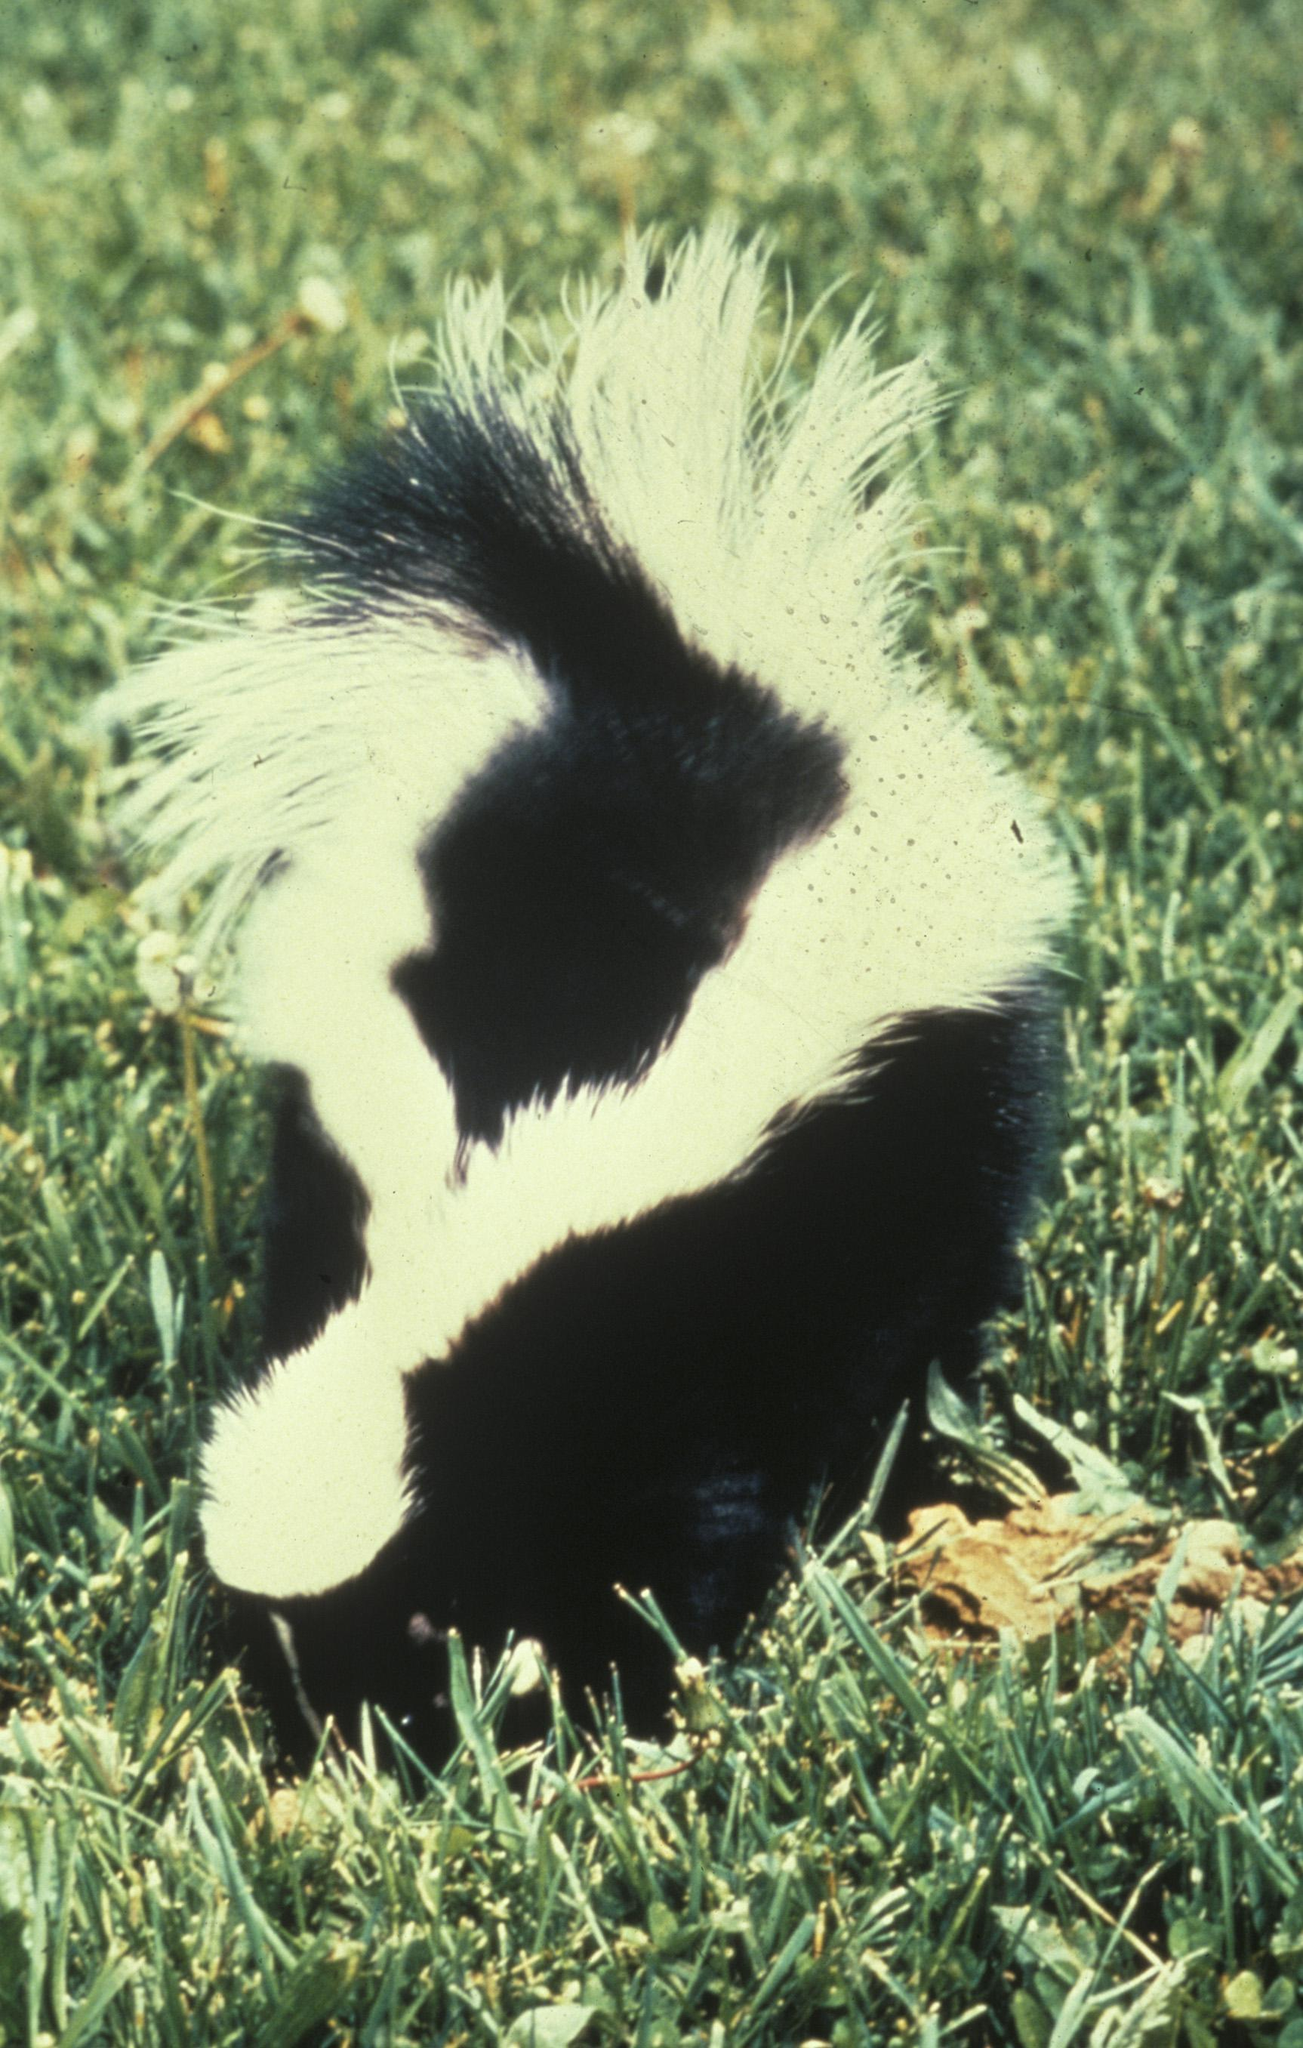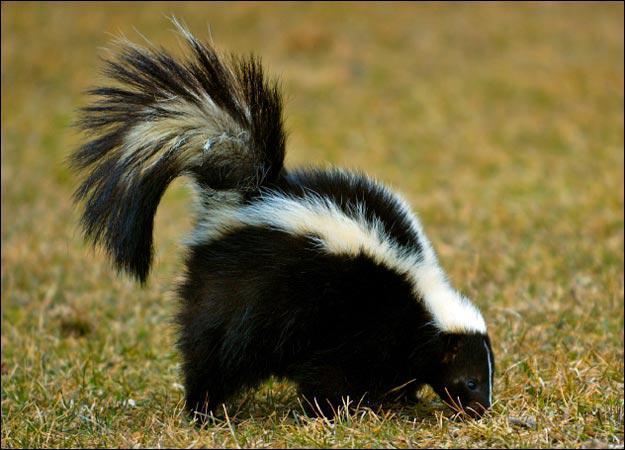The first image is the image on the left, the second image is the image on the right. For the images displayed, is the sentence "One image contains twice as many skunks as the other image." factually correct? Answer yes or no. No. The first image is the image on the left, the second image is the image on the right. For the images shown, is this caption "There are a total of exactly two skunks in the grass." true? Answer yes or no. Yes. 